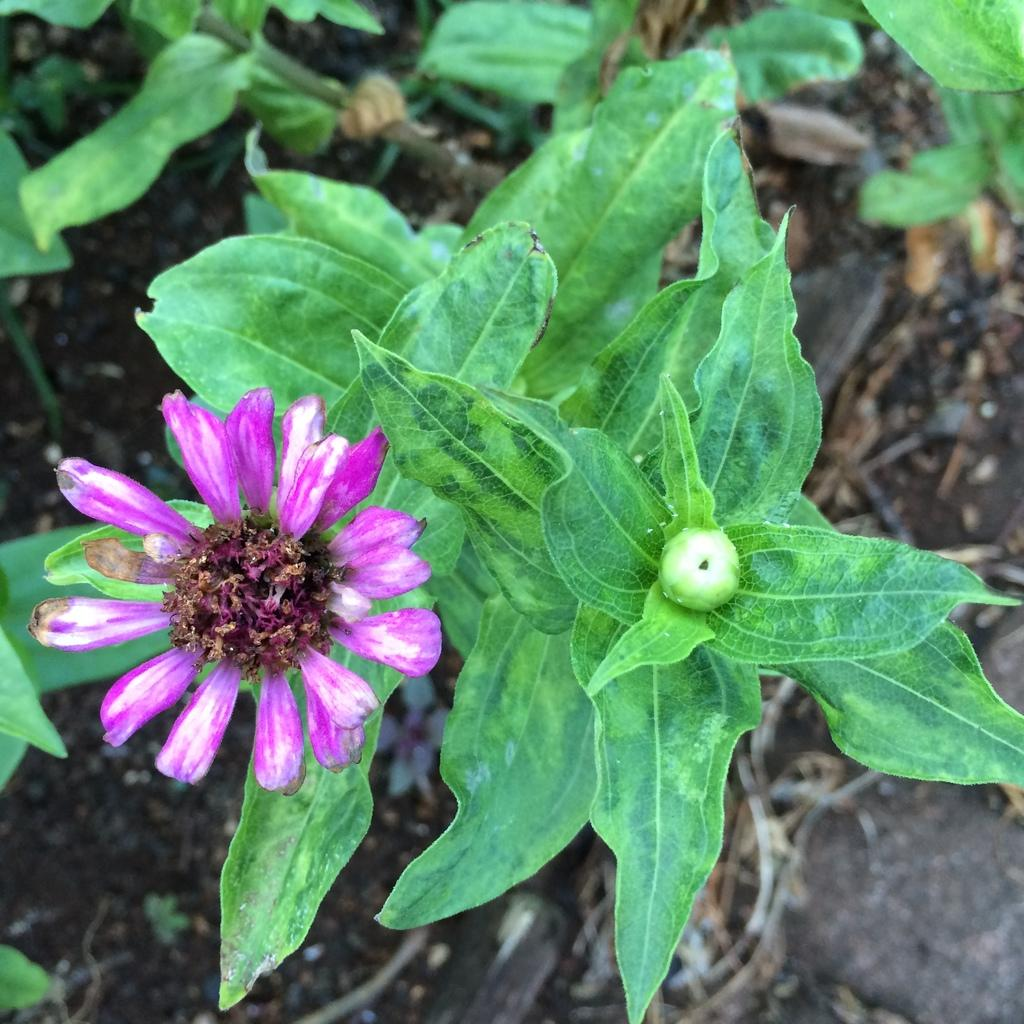What type of plant can be seen in the image? There is a flower in the image. Can you describe the stage of growth of the flower? There is a bud in the image, which suggests the flower is in the early stages of blooming. What other plants are visible in the image? There are plants in the image. How would you describe the background of the image? The background of the image is blurred. How many police officers are present in the image? There are no police officers present in the image; it features a flower, a bud, and other plants. What type of goose can be seen in the image? There is no goose present in the image; it features a flower, a bud, and other plants. 